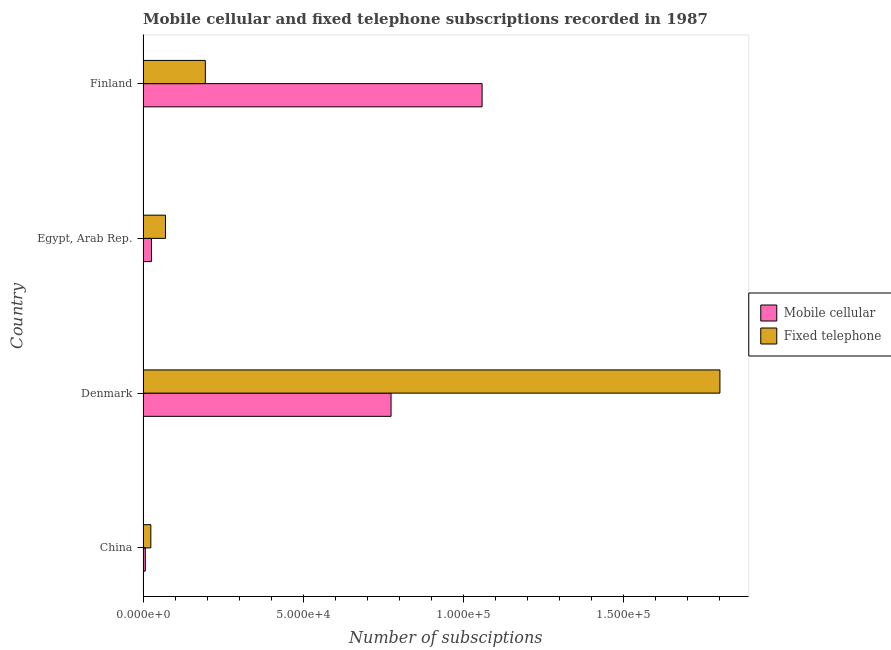How many different coloured bars are there?
Your answer should be compact. 2. How many groups of bars are there?
Ensure brevity in your answer.  4. Are the number of bars per tick equal to the number of legend labels?
Provide a short and direct response. Yes. Are the number of bars on each tick of the Y-axis equal?
Your answer should be compact. Yes. How many bars are there on the 2nd tick from the top?
Offer a terse response. 2. How many bars are there on the 1st tick from the bottom?
Offer a very short reply. 2. What is the number of fixed telephone subscriptions in China?
Your answer should be very brief. 2423. Across all countries, what is the maximum number of mobile cellular subscriptions?
Your response must be concise. 1.06e+05. Across all countries, what is the minimum number of fixed telephone subscriptions?
Keep it short and to the point. 2423. In which country was the number of fixed telephone subscriptions maximum?
Your response must be concise. Denmark. In which country was the number of fixed telephone subscriptions minimum?
Make the answer very short. China. What is the total number of fixed telephone subscriptions in the graph?
Offer a very short reply. 2.09e+05. What is the difference between the number of mobile cellular subscriptions in Denmark and that in Egypt, Arab Rep.?
Provide a succinct answer. 7.48e+04. What is the difference between the number of mobile cellular subscriptions in Finland and the number of fixed telephone subscriptions in Egypt, Arab Rep.?
Provide a succinct answer. 9.89e+04. What is the average number of fixed telephone subscriptions per country?
Keep it short and to the point. 5.22e+04. What is the difference between the number of mobile cellular subscriptions and number of fixed telephone subscriptions in China?
Give a very brief answer. -1723. In how many countries, is the number of fixed telephone subscriptions greater than 90000 ?
Provide a short and direct response. 1. What is the ratio of the number of mobile cellular subscriptions in Denmark to that in Egypt, Arab Rep.?
Keep it short and to the point. 29.48. What is the difference between the highest and the second highest number of mobile cellular subscriptions?
Give a very brief answer. 2.84e+04. What is the difference between the highest and the lowest number of mobile cellular subscriptions?
Your answer should be compact. 1.05e+05. What does the 1st bar from the top in Egypt, Arab Rep. represents?
Your response must be concise. Fixed telephone. What does the 2nd bar from the bottom in Finland represents?
Make the answer very short. Fixed telephone. Are all the bars in the graph horizontal?
Your answer should be compact. Yes. Are the values on the major ticks of X-axis written in scientific E-notation?
Provide a succinct answer. Yes. Does the graph contain any zero values?
Make the answer very short. No. How many legend labels are there?
Your response must be concise. 2. How are the legend labels stacked?
Keep it short and to the point. Vertical. What is the title of the graph?
Your response must be concise. Mobile cellular and fixed telephone subscriptions recorded in 1987. Does "Attending school" appear as one of the legend labels in the graph?
Make the answer very short. No. What is the label or title of the X-axis?
Provide a short and direct response. Number of subsciptions. What is the Number of subsciptions in Mobile cellular in China?
Give a very brief answer. 700. What is the Number of subsciptions in Fixed telephone in China?
Offer a terse response. 2423. What is the Number of subsciptions in Mobile cellular in Denmark?
Give a very brief answer. 7.74e+04. What is the Number of subsciptions of Fixed telephone in Denmark?
Offer a very short reply. 1.80e+05. What is the Number of subsciptions in Mobile cellular in Egypt, Arab Rep.?
Provide a succinct answer. 2627. What is the Number of subsciptions of Fixed telephone in Egypt, Arab Rep.?
Offer a very short reply. 7000. What is the Number of subsciptions in Mobile cellular in Finland?
Keep it short and to the point. 1.06e+05. What is the Number of subsciptions in Fixed telephone in Finland?
Give a very brief answer. 1.94e+04. Across all countries, what is the maximum Number of subsciptions in Mobile cellular?
Keep it short and to the point. 1.06e+05. Across all countries, what is the maximum Number of subsciptions of Fixed telephone?
Your answer should be very brief. 1.80e+05. Across all countries, what is the minimum Number of subsciptions of Mobile cellular?
Your answer should be very brief. 700. Across all countries, what is the minimum Number of subsciptions of Fixed telephone?
Your response must be concise. 2423. What is the total Number of subsciptions of Mobile cellular in the graph?
Offer a terse response. 1.87e+05. What is the total Number of subsciptions in Fixed telephone in the graph?
Provide a succinct answer. 2.09e+05. What is the difference between the Number of subsciptions of Mobile cellular in China and that in Denmark?
Keep it short and to the point. -7.67e+04. What is the difference between the Number of subsciptions in Fixed telephone in China and that in Denmark?
Your answer should be very brief. -1.78e+05. What is the difference between the Number of subsciptions of Mobile cellular in China and that in Egypt, Arab Rep.?
Ensure brevity in your answer.  -1927. What is the difference between the Number of subsciptions of Fixed telephone in China and that in Egypt, Arab Rep.?
Provide a succinct answer. -4577. What is the difference between the Number of subsciptions of Mobile cellular in China and that in Finland?
Your answer should be compact. -1.05e+05. What is the difference between the Number of subsciptions in Fixed telephone in China and that in Finland?
Your answer should be compact. -1.70e+04. What is the difference between the Number of subsciptions in Mobile cellular in Denmark and that in Egypt, Arab Rep.?
Ensure brevity in your answer.  7.48e+04. What is the difference between the Number of subsciptions in Fixed telephone in Denmark and that in Egypt, Arab Rep.?
Offer a very short reply. 1.73e+05. What is the difference between the Number of subsciptions in Mobile cellular in Denmark and that in Finland?
Give a very brief answer. -2.84e+04. What is the difference between the Number of subsciptions in Fixed telephone in Denmark and that in Finland?
Offer a terse response. 1.61e+05. What is the difference between the Number of subsciptions of Mobile cellular in Egypt, Arab Rep. and that in Finland?
Provide a short and direct response. -1.03e+05. What is the difference between the Number of subsciptions of Fixed telephone in Egypt, Arab Rep. and that in Finland?
Your answer should be compact. -1.24e+04. What is the difference between the Number of subsciptions of Mobile cellular in China and the Number of subsciptions of Fixed telephone in Denmark?
Ensure brevity in your answer.  -1.79e+05. What is the difference between the Number of subsciptions of Mobile cellular in China and the Number of subsciptions of Fixed telephone in Egypt, Arab Rep.?
Ensure brevity in your answer.  -6300. What is the difference between the Number of subsciptions of Mobile cellular in China and the Number of subsciptions of Fixed telephone in Finland?
Your response must be concise. -1.87e+04. What is the difference between the Number of subsciptions in Mobile cellular in Denmark and the Number of subsciptions in Fixed telephone in Egypt, Arab Rep.?
Keep it short and to the point. 7.04e+04. What is the difference between the Number of subsciptions in Mobile cellular in Denmark and the Number of subsciptions in Fixed telephone in Finland?
Make the answer very short. 5.80e+04. What is the difference between the Number of subsciptions of Mobile cellular in Egypt, Arab Rep. and the Number of subsciptions of Fixed telephone in Finland?
Your answer should be compact. -1.68e+04. What is the average Number of subsciptions of Mobile cellular per country?
Give a very brief answer. 4.67e+04. What is the average Number of subsciptions of Fixed telephone per country?
Your answer should be very brief. 5.22e+04. What is the difference between the Number of subsciptions of Mobile cellular and Number of subsciptions of Fixed telephone in China?
Give a very brief answer. -1723. What is the difference between the Number of subsciptions in Mobile cellular and Number of subsciptions in Fixed telephone in Denmark?
Provide a short and direct response. -1.03e+05. What is the difference between the Number of subsciptions in Mobile cellular and Number of subsciptions in Fixed telephone in Egypt, Arab Rep.?
Offer a very short reply. -4373. What is the difference between the Number of subsciptions of Mobile cellular and Number of subsciptions of Fixed telephone in Finland?
Your answer should be compact. 8.64e+04. What is the ratio of the Number of subsciptions in Mobile cellular in China to that in Denmark?
Your answer should be compact. 0.01. What is the ratio of the Number of subsciptions in Fixed telephone in China to that in Denmark?
Ensure brevity in your answer.  0.01. What is the ratio of the Number of subsciptions in Mobile cellular in China to that in Egypt, Arab Rep.?
Your response must be concise. 0.27. What is the ratio of the Number of subsciptions in Fixed telephone in China to that in Egypt, Arab Rep.?
Your response must be concise. 0.35. What is the ratio of the Number of subsciptions in Mobile cellular in China to that in Finland?
Your response must be concise. 0.01. What is the ratio of the Number of subsciptions of Fixed telephone in China to that in Finland?
Your answer should be compact. 0.12. What is the ratio of the Number of subsciptions of Mobile cellular in Denmark to that in Egypt, Arab Rep.?
Keep it short and to the point. 29.48. What is the ratio of the Number of subsciptions of Fixed telephone in Denmark to that in Egypt, Arab Rep.?
Give a very brief answer. 25.73. What is the ratio of the Number of subsciptions of Mobile cellular in Denmark to that in Finland?
Provide a succinct answer. 0.73. What is the ratio of the Number of subsciptions of Fixed telephone in Denmark to that in Finland?
Your response must be concise. 9.26. What is the ratio of the Number of subsciptions of Mobile cellular in Egypt, Arab Rep. to that in Finland?
Offer a terse response. 0.02. What is the ratio of the Number of subsciptions of Fixed telephone in Egypt, Arab Rep. to that in Finland?
Make the answer very short. 0.36. What is the difference between the highest and the second highest Number of subsciptions of Mobile cellular?
Make the answer very short. 2.84e+04. What is the difference between the highest and the second highest Number of subsciptions in Fixed telephone?
Provide a short and direct response. 1.61e+05. What is the difference between the highest and the lowest Number of subsciptions of Mobile cellular?
Keep it short and to the point. 1.05e+05. What is the difference between the highest and the lowest Number of subsciptions of Fixed telephone?
Provide a succinct answer. 1.78e+05. 